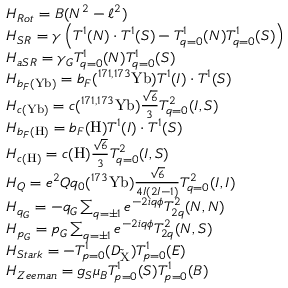<formula> <loc_0><loc_0><loc_500><loc_500>\begin{array} { r l } & { H _ { R o t } = B ( N ^ { 2 } - \ell ^ { 2 } ) } \\ & { H _ { S R } = \gamma \left ( T ^ { 1 } ( N ) \cdot T ^ { 1 } ( S ) - T _ { q = 0 } ^ { 1 } ( N ) T _ { q = 0 } ^ { 1 } ( S ) \right ) } \\ & { H _ { a S R } = \gamma _ { G } T _ { q = 0 } ^ { 1 } ( N ) T _ { q = 0 } ^ { 1 } ( S ) } \\ & { H _ { b _ { F } ( Y b ) } = b _ { F } ( ^ { 1 7 1 , 1 7 3 } Y b ) T ^ { 1 } ( I ) \cdot T ^ { 1 } ( S ) } \\ & { H _ { c ( Y b ) } = c ( ^ { 1 7 1 , 1 7 3 } Y b ) \frac { \sqrt { 6 } } { 3 } T _ { q = 0 } ^ { 2 } ( I , S ) } \\ & { H _ { b _ { F } ( H ) } = b _ { F } ( H ) T ^ { 1 } ( I ) \cdot T ^ { 1 } ( S ) } \\ & { H _ { c ( H ) } = c ( H ) \frac { \sqrt { 6 } } { 3 } T _ { q = 0 } ^ { 2 } ( I , S ) } \\ & { H _ { Q } = e ^ { 2 } Q q _ { 0 } ( ^ { 1 7 3 } Y b ) \frac { \sqrt { 6 } } { 4 I ( 2 I - 1 ) } T _ { q = 0 } ^ { 2 } ( I , I ) } \\ & { H _ { q _ { G } } = - q _ { G } \sum _ { q = \pm 1 } e ^ { - 2 i q \phi } T _ { 2 q } ^ { 2 } ( N , N ) } \\ & { H _ { p _ { G } } = p _ { G } \sum _ { q = \pm 1 } e ^ { - 2 i q \phi } T _ { 2 q } ^ { 2 } ( N , S ) } \\ & { H _ { S t a r k } = - T _ { p = 0 } ^ { 1 } ( D _ { \tilde { X } } ) T _ { p = 0 } ^ { 1 } ( E ) } \\ & { H _ { Z e e m a n } = g _ { S } \mu _ { B } T _ { p = 0 } ^ { 1 } ( S ) T _ { p = 0 } ^ { 1 } ( B ) } \end{array}</formula> 